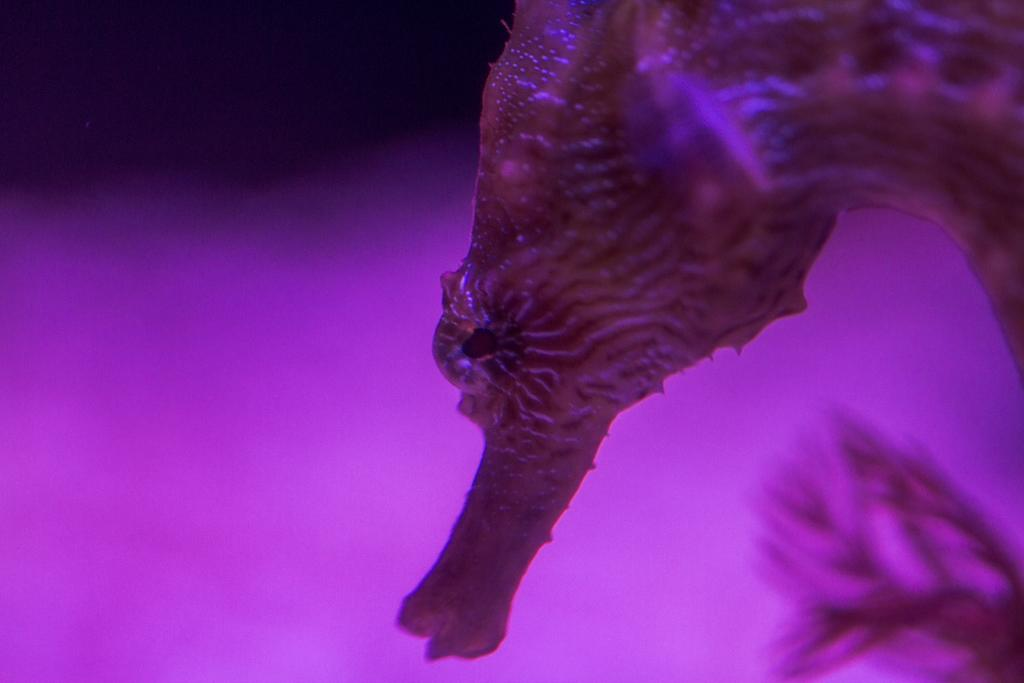What type of animal is in the image? There is a seahorse in the image. What color is the light in the image? There is a pink light in the image. How does the seahorse help with digestion during the rainstorm in the image? There is no rainstorm present in the image, and seahorses do not have a direct role in digestion. 